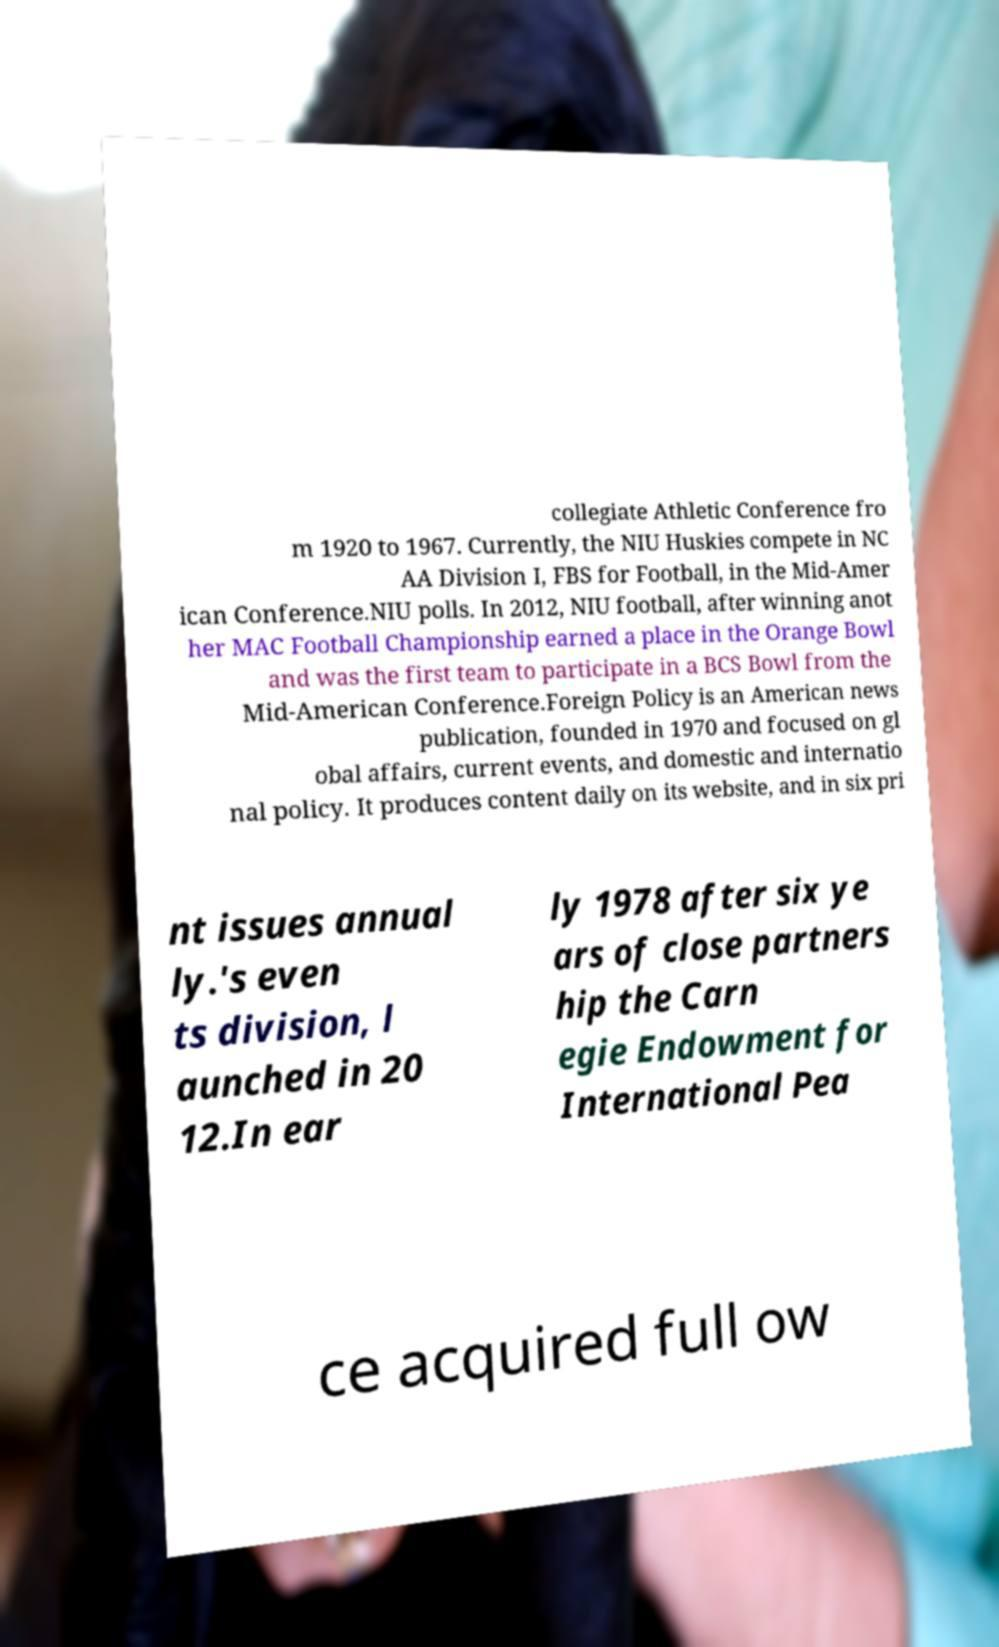For documentation purposes, I need the text within this image transcribed. Could you provide that? collegiate Athletic Conference fro m 1920 to 1967. Currently, the NIU Huskies compete in NC AA Division I, FBS for Football, in the Mid-Amer ican Conference.NIU polls. In 2012, NIU football, after winning anot her MAC Football Championship earned a place in the Orange Bowl and was the first team to participate in a BCS Bowl from the Mid-American Conference.Foreign Policy is an American news publication, founded in 1970 and focused on gl obal affairs, current events, and domestic and internatio nal policy. It produces content daily on its website, and in six pri nt issues annual ly.'s even ts division, l aunched in 20 12.In ear ly 1978 after six ye ars of close partners hip the Carn egie Endowment for International Pea ce acquired full ow 